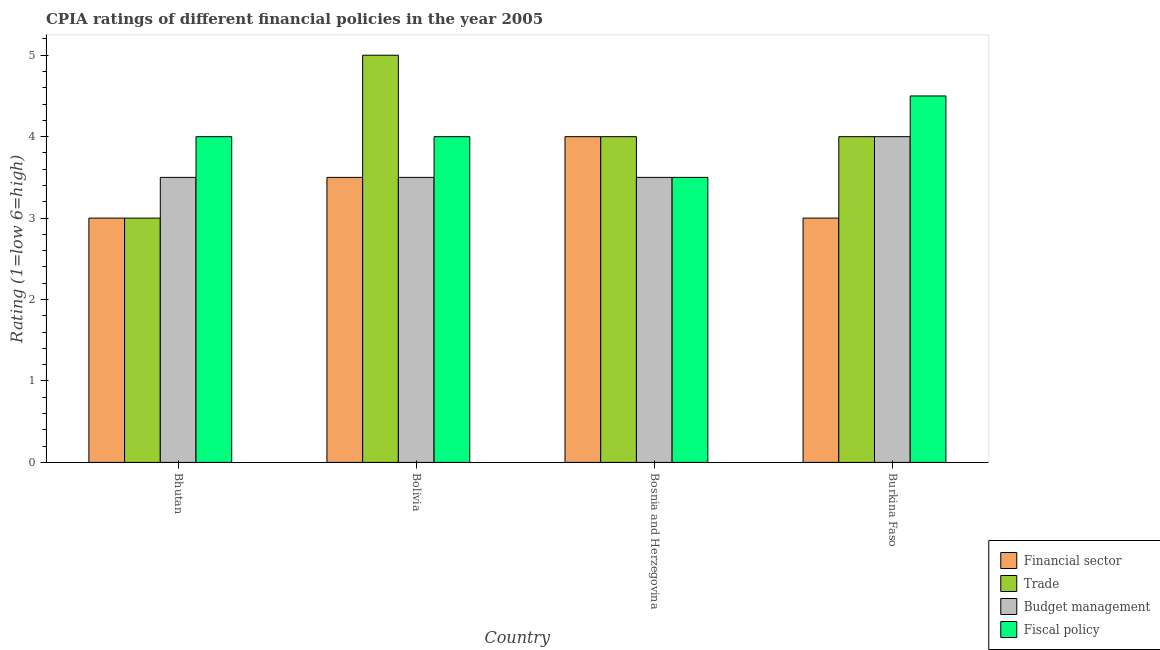How many different coloured bars are there?
Offer a very short reply. 4. Are the number of bars per tick equal to the number of legend labels?
Your answer should be compact. Yes. How many bars are there on the 2nd tick from the left?
Your answer should be very brief. 4. What is the label of the 2nd group of bars from the left?
Give a very brief answer. Bolivia. In how many cases, is the number of bars for a given country not equal to the number of legend labels?
Ensure brevity in your answer.  0. What is the cpia rating of financial sector in Bosnia and Herzegovina?
Make the answer very short. 4. In which country was the cpia rating of fiscal policy maximum?
Your answer should be very brief. Burkina Faso. In which country was the cpia rating of financial sector minimum?
Keep it short and to the point. Bhutan. What is the difference between the cpia rating of budget management in Bosnia and Herzegovina and that in Burkina Faso?
Make the answer very short. -0.5. What is the average cpia rating of trade per country?
Provide a succinct answer. 4. What is the difference between the cpia rating of fiscal policy and cpia rating of budget management in Bosnia and Herzegovina?
Ensure brevity in your answer.  0. In how many countries, is the cpia rating of fiscal policy greater than 4.8 ?
Provide a succinct answer. 0. What is the ratio of the cpia rating of fiscal policy in Bolivia to that in Burkina Faso?
Your answer should be compact. 0.89. Is the cpia rating of fiscal policy in Bosnia and Herzegovina less than that in Burkina Faso?
Give a very brief answer. Yes. Is the difference between the cpia rating of financial sector in Bhutan and Bosnia and Herzegovina greater than the difference between the cpia rating of fiscal policy in Bhutan and Bosnia and Herzegovina?
Offer a terse response. No. What is the difference between the highest and the lowest cpia rating of budget management?
Offer a very short reply. 0.5. Is the sum of the cpia rating of financial sector in Bhutan and Bolivia greater than the maximum cpia rating of trade across all countries?
Provide a short and direct response. Yes. Is it the case that in every country, the sum of the cpia rating of fiscal policy and cpia rating of financial sector is greater than the sum of cpia rating of budget management and cpia rating of trade?
Ensure brevity in your answer.  No. What does the 2nd bar from the left in Bolivia represents?
Your answer should be very brief. Trade. What does the 1st bar from the right in Burkina Faso represents?
Your response must be concise. Fiscal policy. How many bars are there?
Keep it short and to the point. 16. Are all the bars in the graph horizontal?
Provide a succinct answer. No. How many countries are there in the graph?
Provide a succinct answer. 4. What is the difference between two consecutive major ticks on the Y-axis?
Your answer should be compact. 1. Are the values on the major ticks of Y-axis written in scientific E-notation?
Provide a succinct answer. No. Does the graph contain any zero values?
Make the answer very short. No. Where does the legend appear in the graph?
Provide a short and direct response. Bottom right. How are the legend labels stacked?
Offer a very short reply. Vertical. What is the title of the graph?
Provide a short and direct response. CPIA ratings of different financial policies in the year 2005. Does "Custom duties" appear as one of the legend labels in the graph?
Provide a short and direct response. No. What is the label or title of the X-axis?
Offer a terse response. Country. What is the Rating (1=low 6=high) of Financial sector in Bhutan?
Provide a succinct answer. 3. What is the Rating (1=low 6=high) in Trade in Bhutan?
Your response must be concise. 3. What is the Rating (1=low 6=high) of Fiscal policy in Bhutan?
Your answer should be compact. 4. What is the Rating (1=low 6=high) in Financial sector in Bolivia?
Your response must be concise. 3.5. What is the Rating (1=low 6=high) of Trade in Bolivia?
Offer a terse response. 5. What is the Rating (1=low 6=high) in Budget management in Bolivia?
Your response must be concise. 3.5. What is the Rating (1=low 6=high) in Fiscal policy in Bolivia?
Provide a succinct answer. 4. What is the Rating (1=low 6=high) of Trade in Bosnia and Herzegovina?
Make the answer very short. 4. What is the Rating (1=low 6=high) of Trade in Burkina Faso?
Ensure brevity in your answer.  4. Across all countries, what is the maximum Rating (1=low 6=high) of Financial sector?
Give a very brief answer. 4. Across all countries, what is the maximum Rating (1=low 6=high) in Budget management?
Keep it short and to the point. 4. Across all countries, what is the minimum Rating (1=low 6=high) in Financial sector?
Provide a succinct answer. 3. Across all countries, what is the minimum Rating (1=low 6=high) in Trade?
Your answer should be very brief. 3. Across all countries, what is the minimum Rating (1=low 6=high) of Budget management?
Keep it short and to the point. 3.5. Across all countries, what is the minimum Rating (1=low 6=high) in Fiscal policy?
Ensure brevity in your answer.  3.5. What is the total Rating (1=low 6=high) in Budget management in the graph?
Your response must be concise. 14.5. What is the difference between the Rating (1=low 6=high) of Financial sector in Bhutan and that in Bolivia?
Provide a succinct answer. -0.5. What is the difference between the Rating (1=low 6=high) in Trade in Bhutan and that in Bolivia?
Offer a terse response. -2. What is the difference between the Rating (1=low 6=high) in Budget management in Bhutan and that in Bolivia?
Make the answer very short. 0. What is the difference between the Rating (1=low 6=high) of Fiscal policy in Bhutan and that in Bolivia?
Your answer should be compact. 0. What is the difference between the Rating (1=low 6=high) of Financial sector in Bhutan and that in Bosnia and Herzegovina?
Provide a succinct answer. -1. What is the difference between the Rating (1=low 6=high) of Trade in Bhutan and that in Bosnia and Herzegovina?
Your response must be concise. -1. What is the difference between the Rating (1=low 6=high) of Fiscal policy in Bhutan and that in Bosnia and Herzegovina?
Keep it short and to the point. 0.5. What is the difference between the Rating (1=low 6=high) of Trade in Bhutan and that in Burkina Faso?
Offer a very short reply. -1. What is the difference between the Rating (1=low 6=high) in Fiscal policy in Bhutan and that in Burkina Faso?
Keep it short and to the point. -0.5. What is the difference between the Rating (1=low 6=high) of Financial sector in Bolivia and that in Bosnia and Herzegovina?
Make the answer very short. -0.5. What is the difference between the Rating (1=low 6=high) of Trade in Bolivia and that in Bosnia and Herzegovina?
Keep it short and to the point. 1. What is the difference between the Rating (1=low 6=high) in Budget management in Bolivia and that in Bosnia and Herzegovina?
Your answer should be very brief. 0. What is the difference between the Rating (1=low 6=high) of Fiscal policy in Bolivia and that in Bosnia and Herzegovina?
Make the answer very short. 0.5. What is the difference between the Rating (1=low 6=high) of Financial sector in Bolivia and that in Burkina Faso?
Ensure brevity in your answer.  0.5. What is the difference between the Rating (1=low 6=high) of Trade in Bolivia and that in Burkina Faso?
Offer a very short reply. 1. What is the difference between the Rating (1=low 6=high) of Budget management in Bolivia and that in Burkina Faso?
Make the answer very short. -0.5. What is the difference between the Rating (1=low 6=high) of Fiscal policy in Bolivia and that in Burkina Faso?
Your answer should be very brief. -0.5. What is the difference between the Rating (1=low 6=high) of Budget management in Bosnia and Herzegovina and that in Burkina Faso?
Provide a short and direct response. -0.5. What is the difference between the Rating (1=low 6=high) of Fiscal policy in Bosnia and Herzegovina and that in Burkina Faso?
Provide a short and direct response. -1. What is the difference between the Rating (1=low 6=high) in Financial sector in Bhutan and the Rating (1=low 6=high) in Fiscal policy in Bolivia?
Provide a succinct answer. -1. What is the difference between the Rating (1=low 6=high) of Budget management in Bhutan and the Rating (1=low 6=high) of Fiscal policy in Bolivia?
Provide a succinct answer. -0.5. What is the difference between the Rating (1=low 6=high) in Financial sector in Bhutan and the Rating (1=low 6=high) in Budget management in Bosnia and Herzegovina?
Your answer should be compact. -0.5. What is the difference between the Rating (1=low 6=high) in Financial sector in Bhutan and the Rating (1=low 6=high) in Fiscal policy in Bosnia and Herzegovina?
Give a very brief answer. -0.5. What is the difference between the Rating (1=low 6=high) in Trade in Bhutan and the Rating (1=low 6=high) in Budget management in Burkina Faso?
Make the answer very short. -1. What is the difference between the Rating (1=low 6=high) in Trade in Bhutan and the Rating (1=low 6=high) in Fiscal policy in Burkina Faso?
Your answer should be very brief. -1.5. What is the difference between the Rating (1=low 6=high) of Budget management in Bhutan and the Rating (1=low 6=high) of Fiscal policy in Burkina Faso?
Your answer should be compact. -1. What is the difference between the Rating (1=low 6=high) in Financial sector in Bolivia and the Rating (1=low 6=high) in Budget management in Bosnia and Herzegovina?
Ensure brevity in your answer.  0. What is the difference between the Rating (1=low 6=high) in Trade in Bolivia and the Rating (1=low 6=high) in Fiscal policy in Bosnia and Herzegovina?
Give a very brief answer. 1.5. What is the difference between the Rating (1=low 6=high) of Financial sector in Bolivia and the Rating (1=low 6=high) of Trade in Burkina Faso?
Offer a very short reply. -0.5. What is the difference between the Rating (1=low 6=high) of Financial sector in Bolivia and the Rating (1=low 6=high) of Budget management in Burkina Faso?
Ensure brevity in your answer.  -0.5. What is the difference between the Rating (1=low 6=high) of Financial sector in Bolivia and the Rating (1=low 6=high) of Fiscal policy in Burkina Faso?
Give a very brief answer. -1. What is the difference between the Rating (1=low 6=high) in Trade in Bolivia and the Rating (1=low 6=high) in Fiscal policy in Burkina Faso?
Ensure brevity in your answer.  0.5. What is the difference between the Rating (1=low 6=high) of Financial sector in Bosnia and Herzegovina and the Rating (1=low 6=high) of Trade in Burkina Faso?
Your answer should be compact. 0. What is the difference between the Rating (1=low 6=high) in Financial sector in Bosnia and Herzegovina and the Rating (1=low 6=high) in Fiscal policy in Burkina Faso?
Provide a succinct answer. -0.5. What is the difference between the Rating (1=low 6=high) in Trade in Bosnia and Herzegovina and the Rating (1=low 6=high) in Budget management in Burkina Faso?
Your response must be concise. 0. What is the difference between the Rating (1=low 6=high) of Trade in Bosnia and Herzegovina and the Rating (1=low 6=high) of Fiscal policy in Burkina Faso?
Offer a very short reply. -0.5. What is the difference between the Rating (1=low 6=high) in Budget management in Bosnia and Herzegovina and the Rating (1=low 6=high) in Fiscal policy in Burkina Faso?
Your answer should be very brief. -1. What is the average Rating (1=low 6=high) in Financial sector per country?
Offer a terse response. 3.38. What is the average Rating (1=low 6=high) of Budget management per country?
Provide a short and direct response. 3.62. What is the average Rating (1=low 6=high) of Fiscal policy per country?
Provide a succinct answer. 4. What is the difference between the Rating (1=low 6=high) of Financial sector and Rating (1=low 6=high) of Trade in Bhutan?
Your response must be concise. 0. What is the difference between the Rating (1=low 6=high) of Trade and Rating (1=low 6=high) of Budget management in Bhutan?
Provide a succinct answer. -0.5. What is the difference between the Rating (1=low 6=high) of Trade and Rating (1=low 6=high) of Fiscal policy in Bhutan?
Your response must be concise. -1. What is the difference between the Rating (1=low 6=high) in Budget management and Rating (1=low 6=high) in Fiscal policy in Bhutan?
Offer a terse response. -0.5. What is the difference between the Rating (1=low 6=high) in Financial sector and Rating (1=low 6=high) in Trade in Bolivia?
Provide a short and direct response. -1.5. What is the difference between the Rating (1=low 6=high) in Financial sector and Rating (1=low 6=high) in Budget management in Bolivia?
Offer a very short reply. 0. What is the difference between the Rating (1=low 6=high) of Trade and Rating (1=low 6=high) of Fiscal policy in Bolivia?
Provide a short and direct response. 1. What is the difference between the Rating (1=low 6=high) in Budget management and Rating (1=low 6=high) in Fiscal policy in Bolivia?
Ensure brevity in your answer.  -0.5. What is the difference between the Rating (1=low 6=high) in Financial sector and Rating (1=low 6=high) in Budget management in Bosnia and Herzegovina?
Your response must be concise. 0.5. What is the difference between the Rating (1=low 6=high) in Trade and Rating (1=low 6=high) in Budget management in Bosnia and Herzegovina?
Give a very brief answer. 0.5. What is the difference between the Rating (1=low 6=high) of Trade and Rating (1=low 6=high) of Fiscal policy in Bosnia and Herzegovina?
Provide a short and direct response. 0.5. What is the difference between the Rating (1=low 6=high) in Financial sector and Rating (1=low 6=high) in Trade in Burkina Faso?
Provide a succinct answer. -1. What is the difference between the Rating (1=low 6=high) in Financial sector and Rating (1=low 6=high) in Budget management in Burkina Faso?
Offer a very short reply. -1. What is the difference between the Rating (1=low 6=high) in Financial sector and Rating (1=low 6=high) in Fiscal policy in Burkina Faso?
Your answer should be compact. -1.5. What is the difference between the Rating (1=low 6=high) of Budget management and Rating (1=low 6=high) of Fiscal policy in Burkina Faso?
Keep it short and to the point. -0.5. What is the ratio of the Rating (1=low 6=high) in Financial sector in Bhutan to that in Bolivia?
Your response must be concise. 0.86. What is the ratio of the Rating (1=low 6=high) of Budget management in Bhutan to that in Bolivia?
Offer a very short reply. 1. What is the ratio of the Rating (1=low 6=high) of Fiscal policy in Bhutan to that in Bolivia?
Keep it short and to the point. 1. What is the ratio of the Rating (1=low 6=high) in Financial sector in Bhutan to that in Bosnia and Herzegovina?
Your answer should be very brief. 0.75. What is the ratio of the Rating (1=low 6=high) of Trade in Bhutan to that in Bosnia and Herzegovina?
Provide a succinct answer. 0.75. What is the ratio of the Rating (1=low 6=high) of Financial sector in Bhutan to that in Burkina Faso?
Provide a short and direct response. 1. What is the ratio of the Rating (1=low 6=high) in Trade in Bhutan to that in Burkina Faso?
Your response must be concise. 0.75. What is the ratio of the Rating (1=low 6=high) in Budget management in Bhutan to that in Burkina Faso?
Provide a short and direct response. 0.88. What is the ratio of the Rating (1=low 6=high) of Financial sector in Bolivia to that in Burkina Faso?
Ensure brevity in your answer.  1.17. What is the ratio of the Rating (1=low 6=high) in Budget management in Bolivia to that in Burkina Faso?
Keep it short and to the point. 0.88. What is the ratio of the Rating (1=low 6=high) in Financial sector in Bosnia and Herzegovina to that in Burkina Faso?
Offer a terse response. 1.33. What is the ratio of the Rating (1=low 6=high) of Trade in Bosnia and Herzegovina to that in Burkina Faso?
Make the answer very short. 1. What is the ratio of the Rating (1=low 6=high) of Fiscal policy in Bosnia and Herzegovina to that in Burkina Faso?
Provide a succinct answer. 0.78. What is the difference between the highest and the second highest Rating (1=low 6=high) of Budget management?
Provide a succinct answer. 0.5. What is the difference between the highest and the lowest Rating (1=low 6=high) in Financial sector?
Make the answer very short. 1. What is the difference between the highest and the lowest Rating (1=low 6=high) in Trade?
Provide a succinct answer. 2. What is the difference between the highest and the lowest Rating (1=low 6=high) in Budget management?
Your answer should be compact. 0.5. 